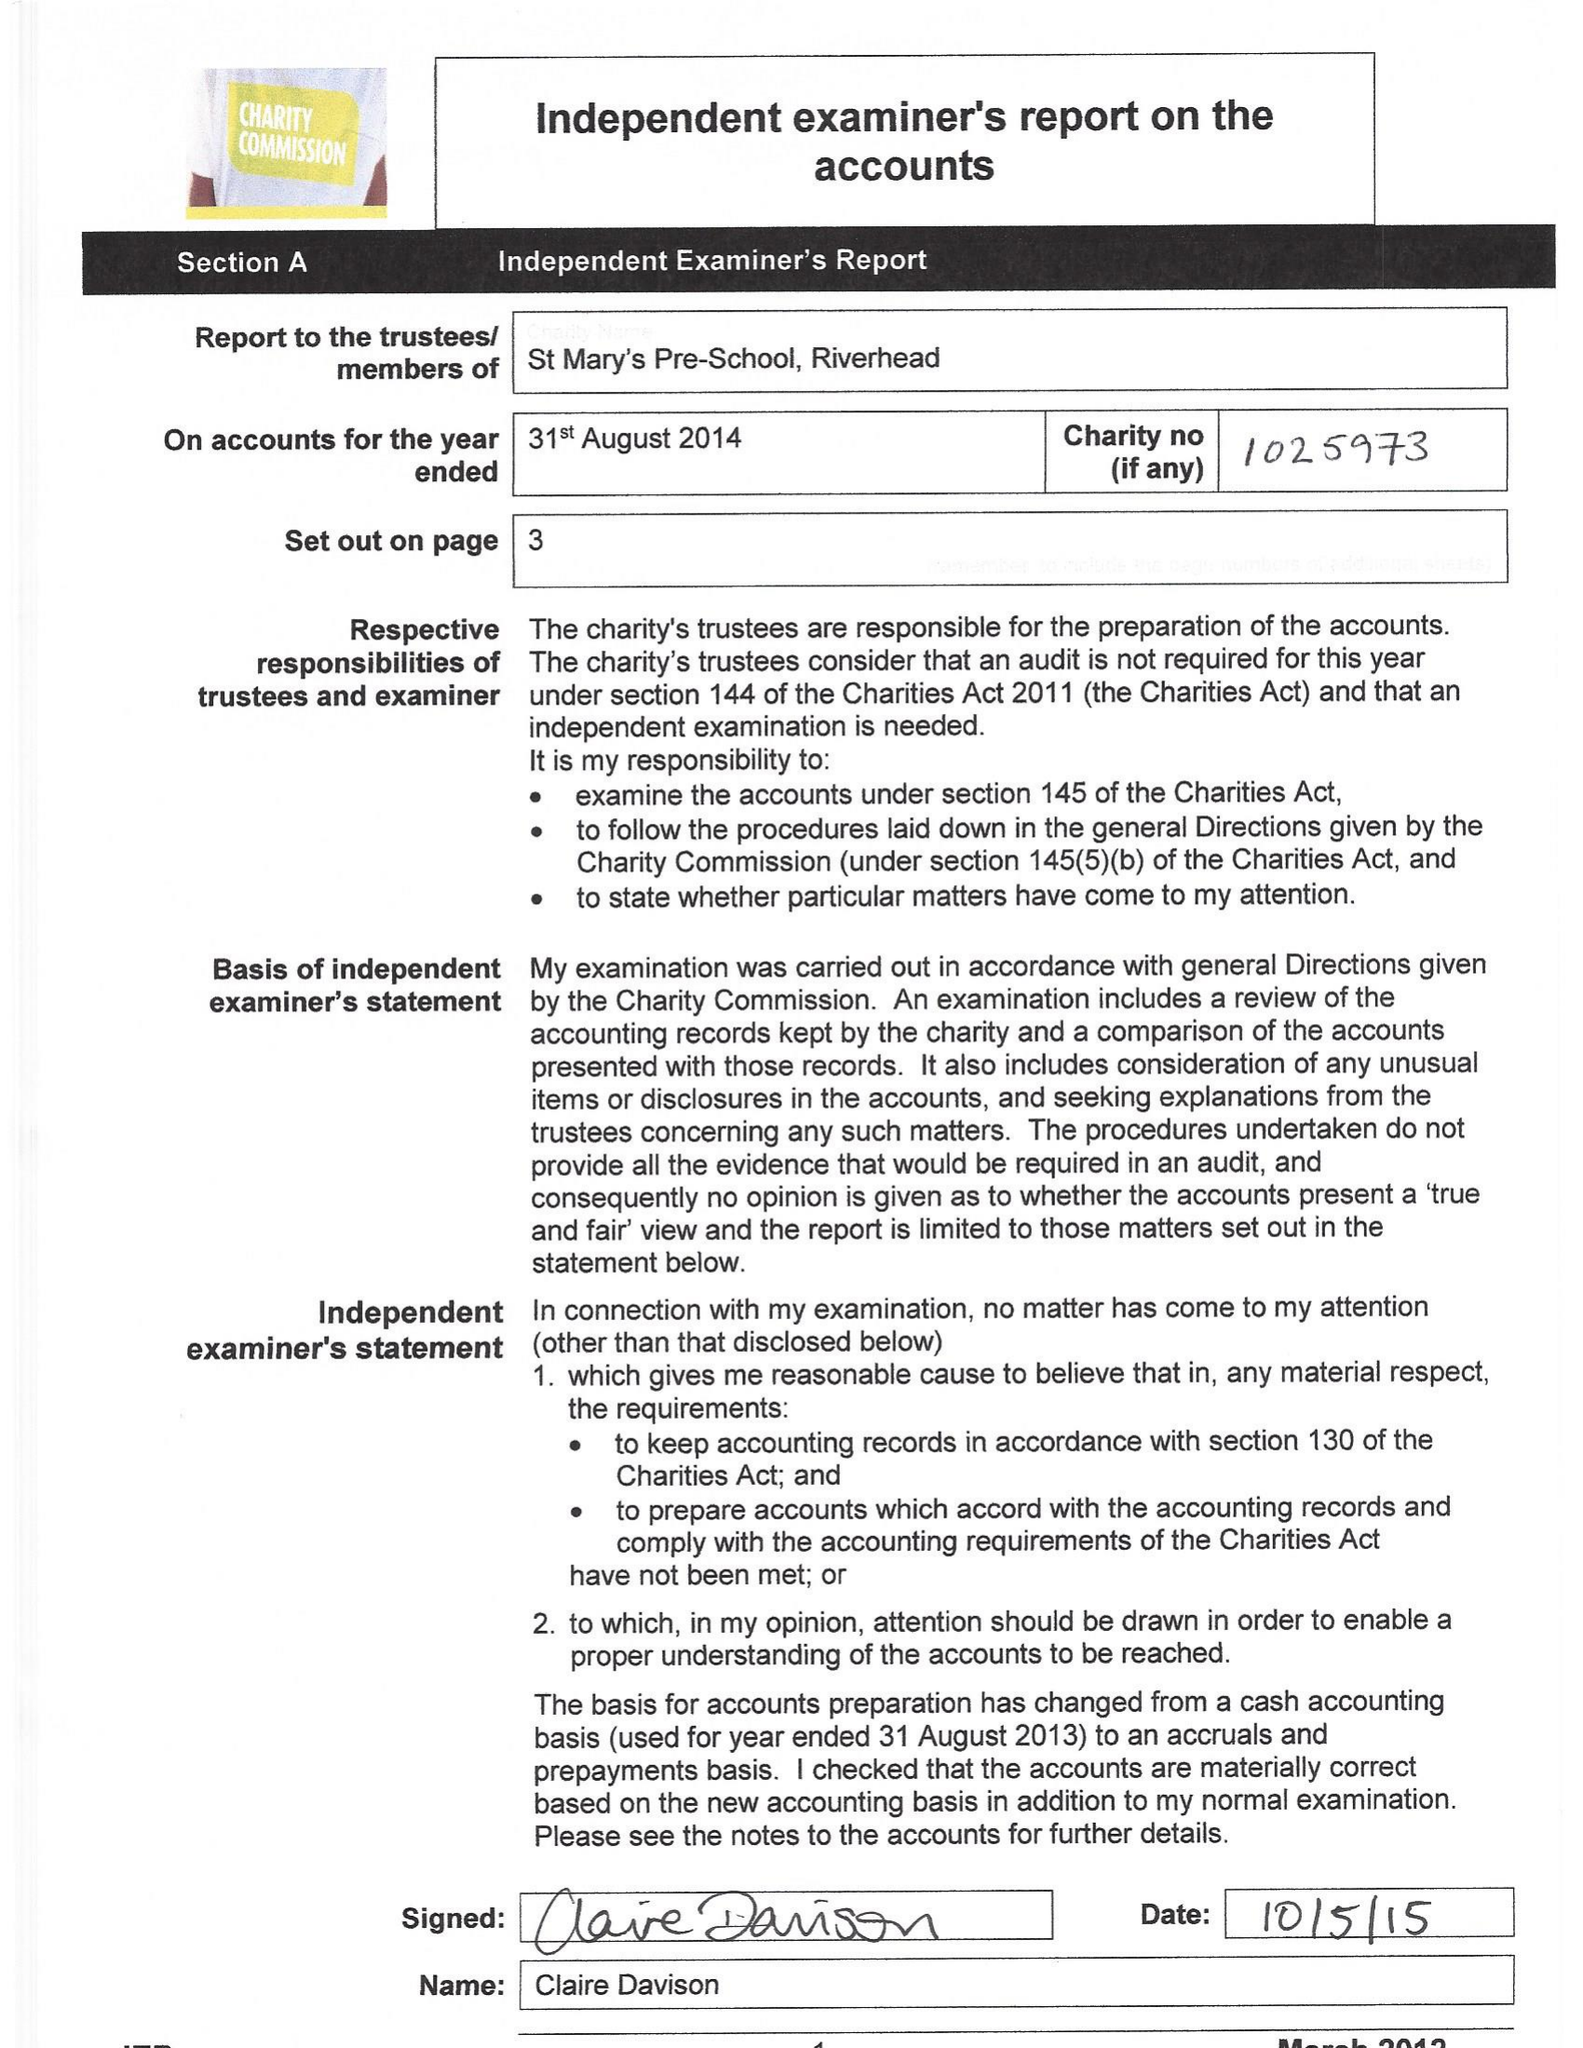What is the value for the address__post_town?
Answer the question using a single word or phrase. SEVENOAKS 